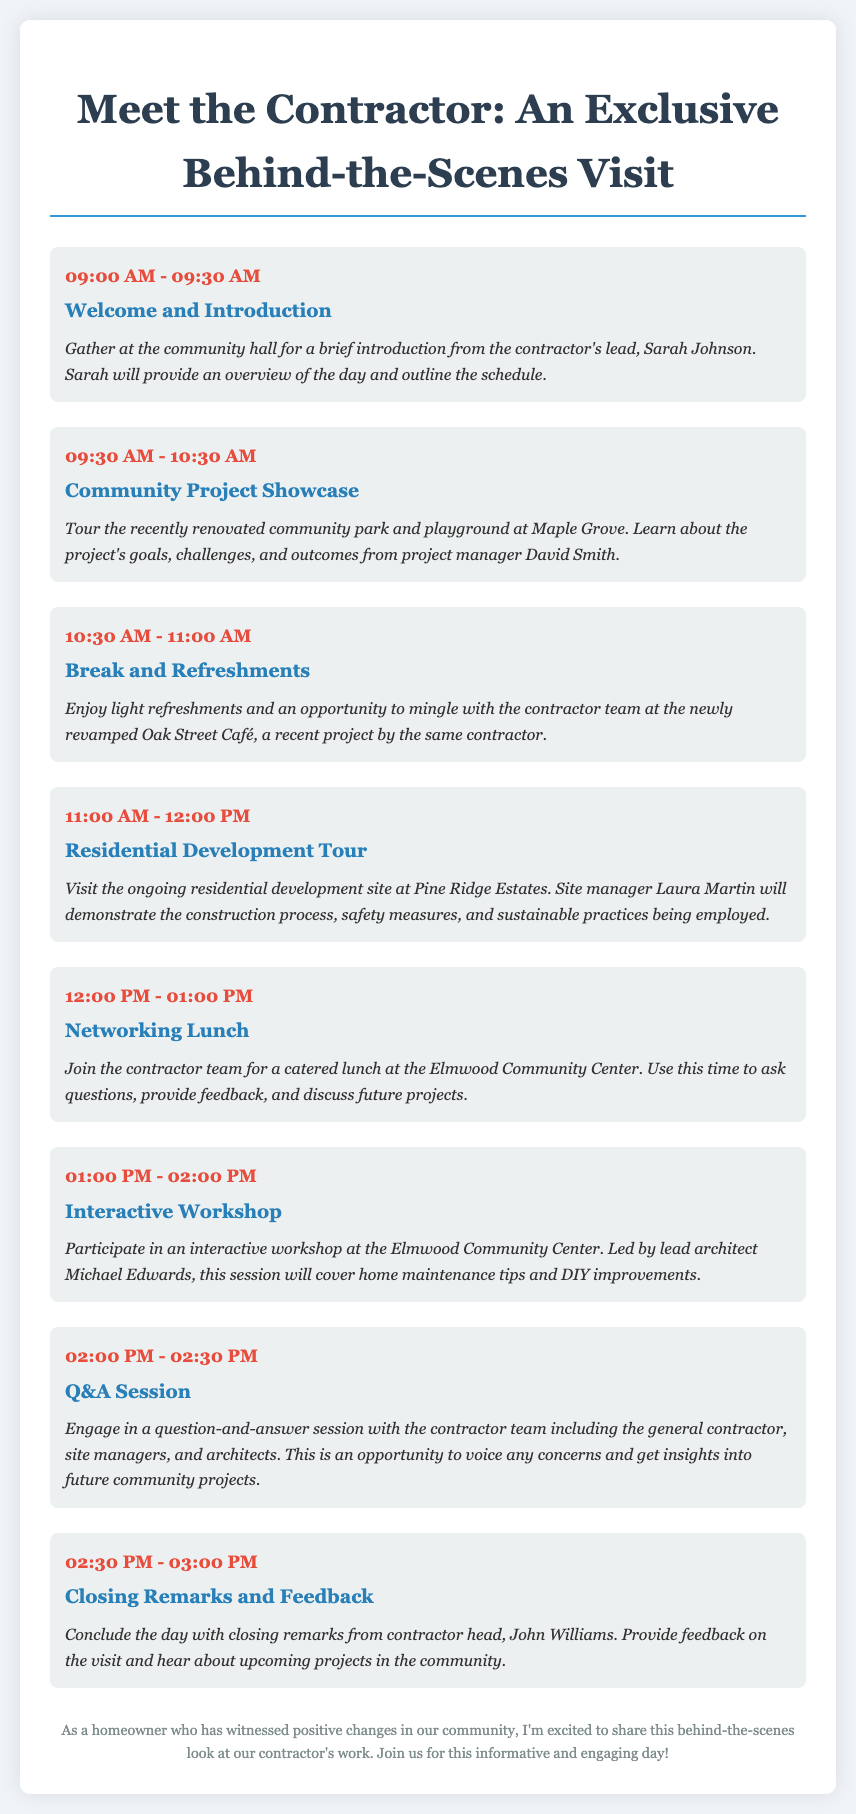What time does the welcome and introduction start? The itinerary lists the welcome and introduction starting at 09:00 AM.
Answer: 09:00 AM Who provides the overview of the day? The overview of the day is provided by the contractor's lead, Sarah Johnson.
Answer: Sarah Johnson What community project is showcased during the tour? The showcased project is the recently renovated community park and playground at Maple Grove.
Answer: community park and playground at Maple Grove How long is the networking lunch? The networking lunch lasts for one hour, from 12:00 PM to 01:00 PM.
Answer: one hour What is the focus of the interactive workshop? The focus of the interactive workshop is home maintenance tips and DIY improvements.
Answer: home maintenance tips and DIY improvements What type of session follows the interactive workshop? A question-and-answer session follows the interactive workshop.
Answer: question-and-answer session How will participants engage with the contractor team during the event? Participants will engage through a Q&A session, providing an opportunity to voice concerns and get insights.
Answer: Q&A session Who will conclude the day with closing remarks? The day will be concluded with closing remarks from the contractor head, John Williams.
Answer: John Williams 